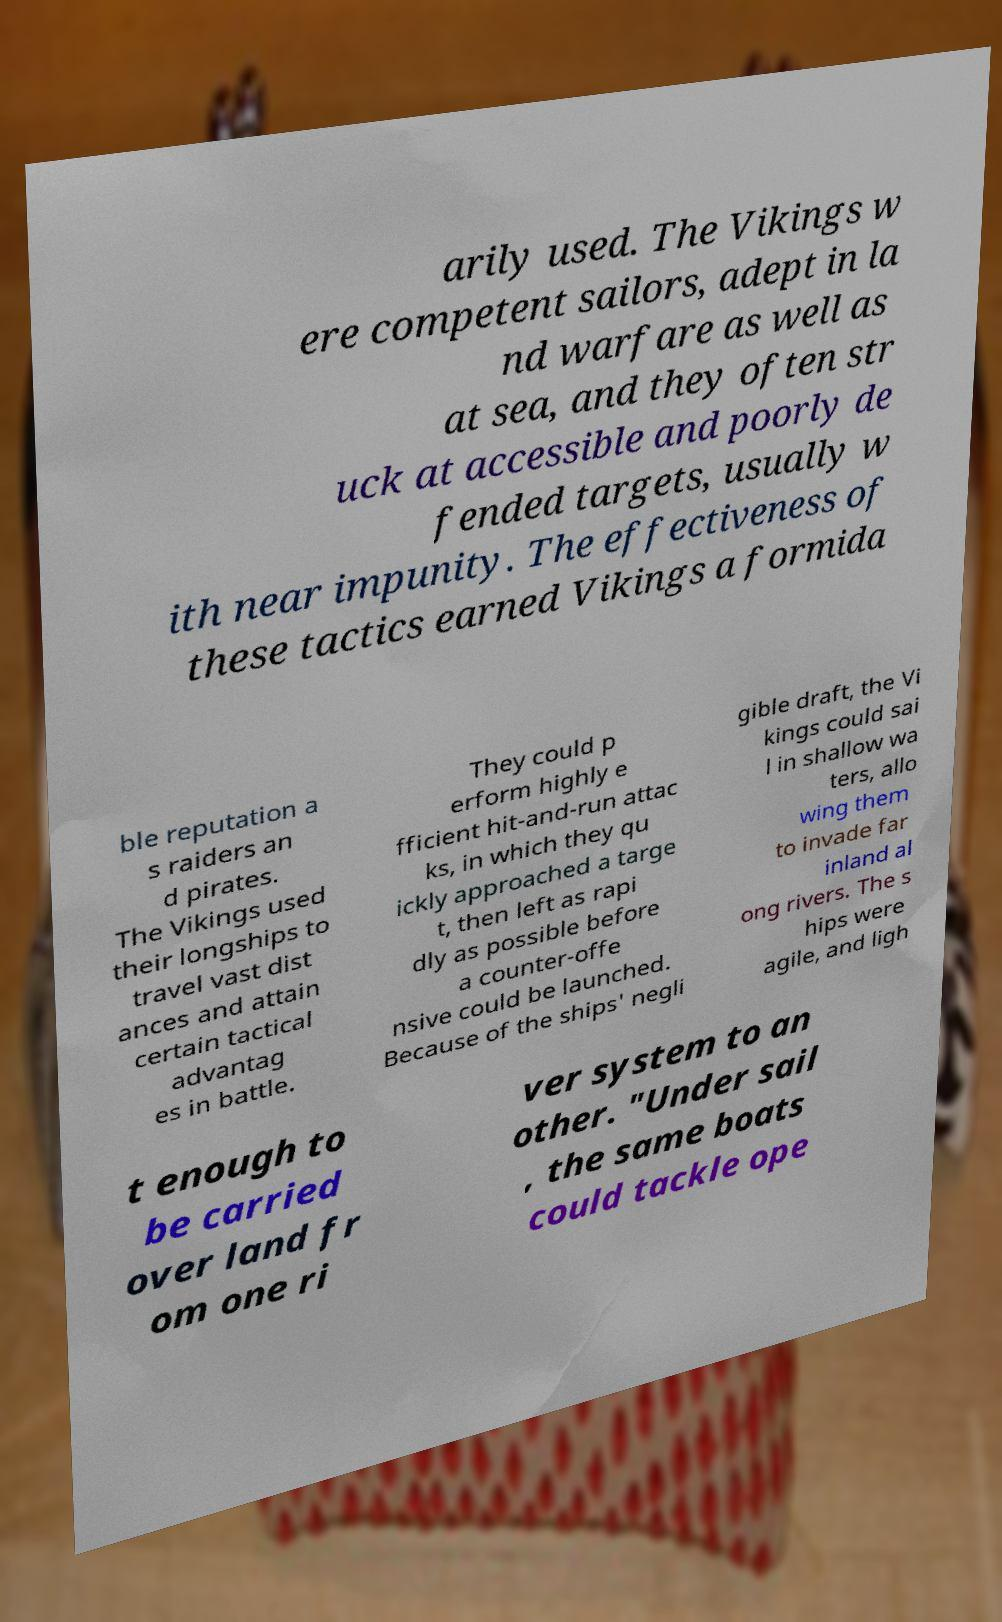There's text embedded in this image that I need extracted. Can you transcribe it verbatim? arily used. The Vikings w ere competent sailors, adept in la nd warfare as well as at sea, and they often str uck at accessible and poorly de fended targets, usually w ith near impunity. The effectiveness of these tactics earned Vikings a formida ble reputation a s raiders an d pirates. The Vikings used their longships to travel vast dist ances and attain certain tactical advantag es in battle. They could p erform highly e fficient hit-and-run attac ks, in which they qu ickly approached a targe t, then left as rapi dly as possible before a counter-offe nsive could be launched. Because of the ships' negli gible draft, the Vi kings could sai l in shallow wa ters, allo wing them to invade far inland al ong rivers. The s hips were agile, and ligh t enough to be carried over land fr om one ri ver system to an other. "Under sail , the same boats could tackle ope 